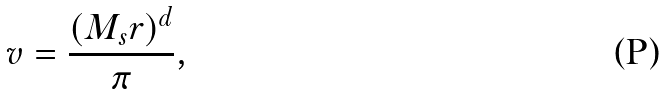<formula> <loc_0><loc_0><loc_500><loc_500>v = \frac { ( M _ { s } r ) ^ { d } } { \pi } ,</formula> 